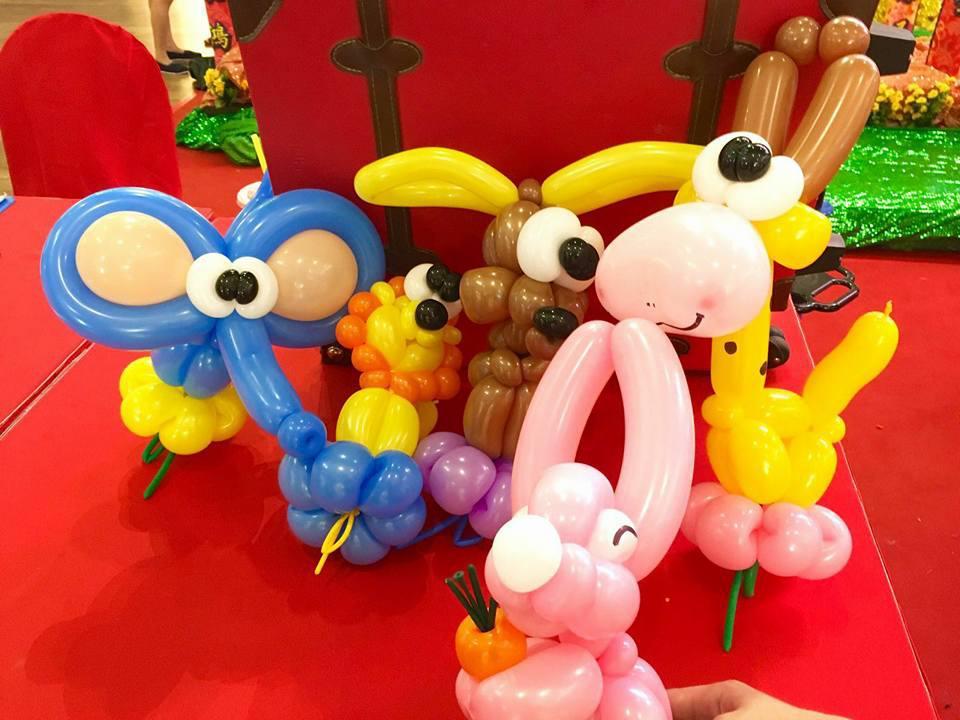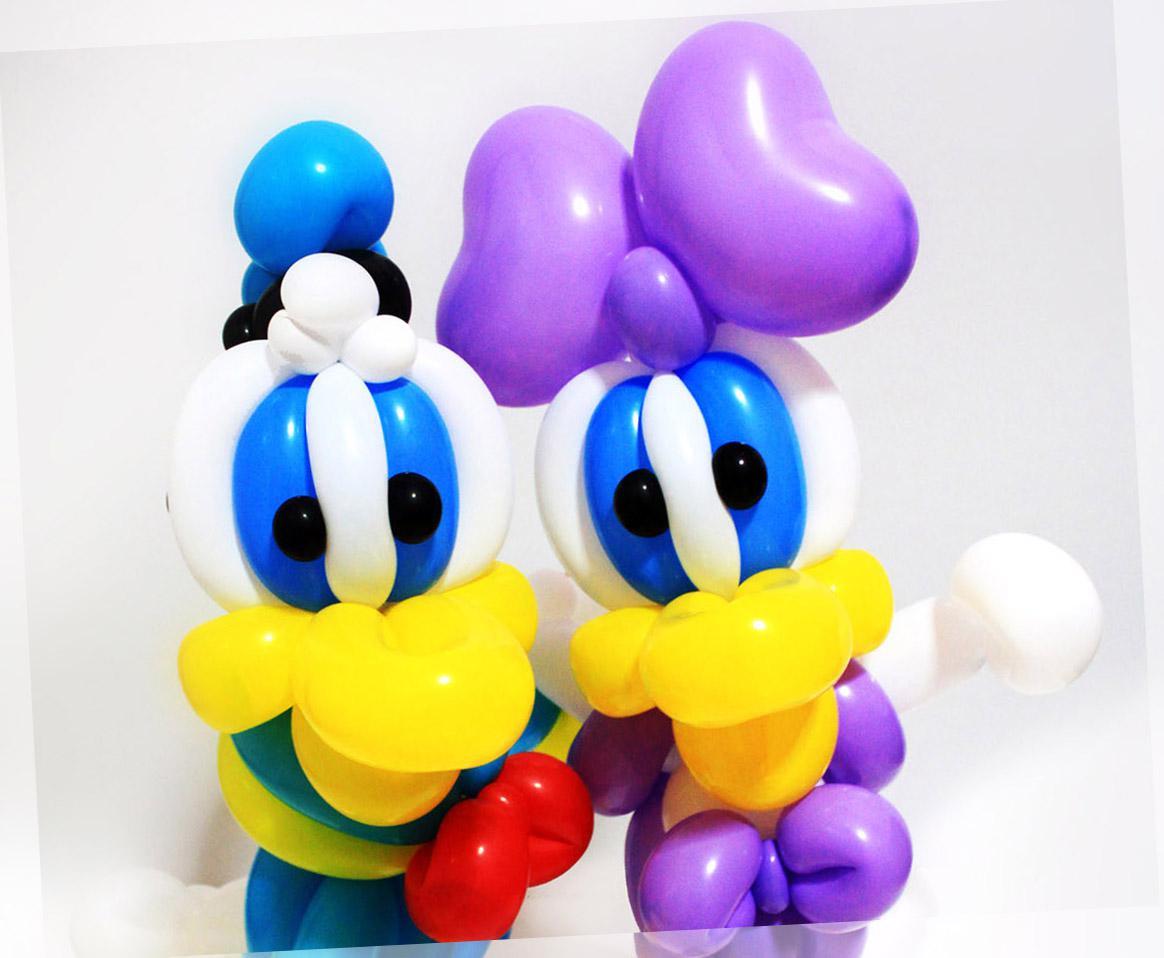The first image is the image on the left, the second image is the image on the right. Given the left and right images, does the statement "One of the balloons is shaped like spiderman." hold true? Answer yes or no. No. 